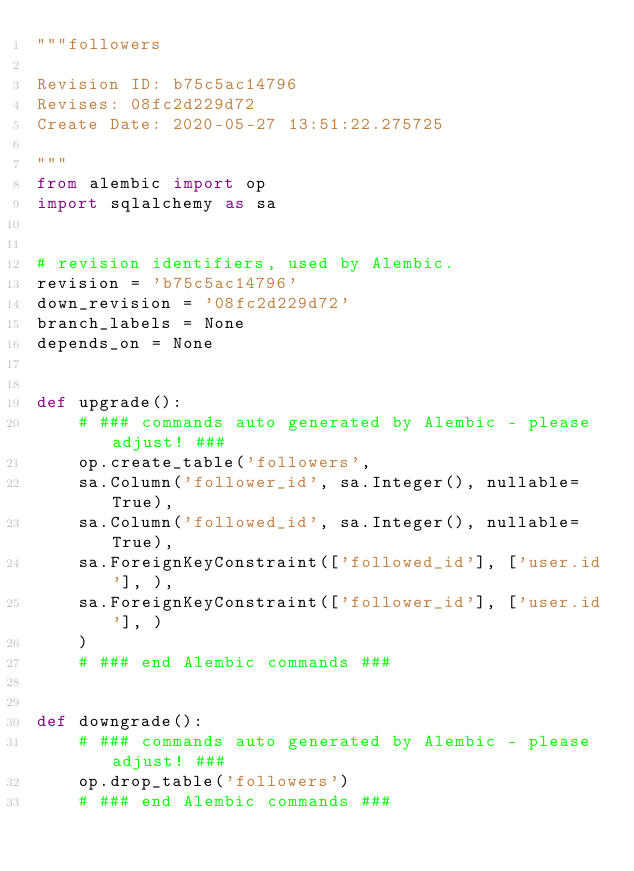<code> <loc_0><loc_0><loc_500><loc_500><_Python_>"""followers

Revision ID: b75c5ac14796
Revises: 08fc2d229d72
Create Date: 2020-05-27 13:51:22.275725

"""
from alembic import op
import sqlalchemy as sa


# revision identifiers, used by Alembic.
revision = 'b75c5ac14796'
down_revision = '08fc2d229d72'
branch_labels = None
depends_on = None


def upgrade():
    # ### commands auto generated by Alembic - please adjust! ###
    op.create_table('followers',
    sa.Column('follower_id', sa.Integer(), nullable=True),
    sa.Column('followed_id', sa.Integer(), nullable=True),
    sa.ForeignKeyConstraint(['followed_id'], ['user.id'], ),
    sa.ForeignKeyConstraint(['follower_id'], ['user.id'], )
    )
    # ### end Alembic commands ###


def downgrade():
    # ### commands auto generated by Alembic - please adjust! ###
    op.drop_table('followers')
    # ### end Alembic commands ###
</code> 